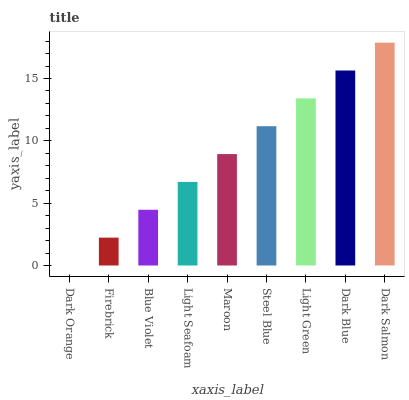Is Firebrick the minimum?
Answer yes or no. No. Is Firebrick the maximum?
Answer yes or no. No. Is Firebrick greater than Dark Orange?
Answer yes or no. Yes. Is Dark Orange less than Firebrick?
Answer yes or no. Yes. Is Dark Orange greater than Firebrick?
Answer yes or no. No. Is Firebrick less than Dark Orange?
Answer yes or no. No. Is Maroon the high median?
Answer yes or no. Yes. Is Maroon the low median?
Answer yes or no. Yes. Is Dark Blue the high median?
Answer yes or no. No. Is Blue Violet the low median?
Answer yes or no. No. 